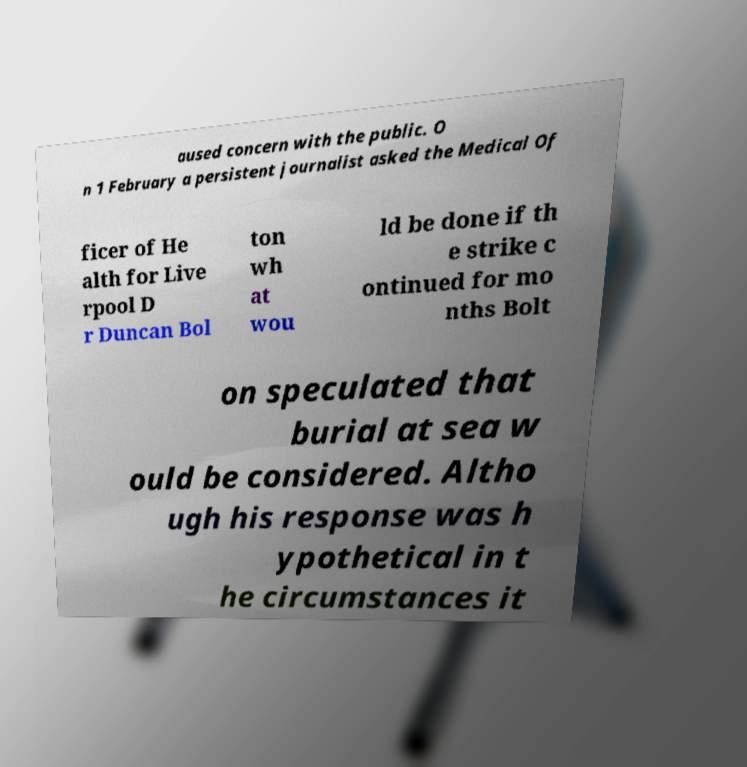Could you extract and type out the text from this image? aused concern with the public. O n 1 February a persistent journalist asked the Medical Of ficer of He alth for Live rpool D r Duncan Bol ton wh at wou ld be done if th e strike c ontinued for mo nths Bolt on speculated that burial at sea w ould be considered. Altho ugh his response was h ypothetical in t he circumstances it 